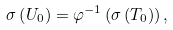Convert formula to latex. <formula><loc_0><loc_0><loc_500><loc_500>\sigma \left ( U _ { 0 } \right ) = \varphi ^ { - 1 } \left ( \sigma \left ( T _ { 0 } \right ) \right ) ,</formula> 